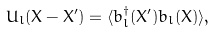<formula> <loc_0><loc_0><loc_500><loc_500>U _ { l } ( { X } - { X } ^ { \prime } ) = \langle b _ { l } ^ { \dagger } ( { X } ^ { \prime } ) b _ { l } ( { X } ) \rangle ,</formula> 